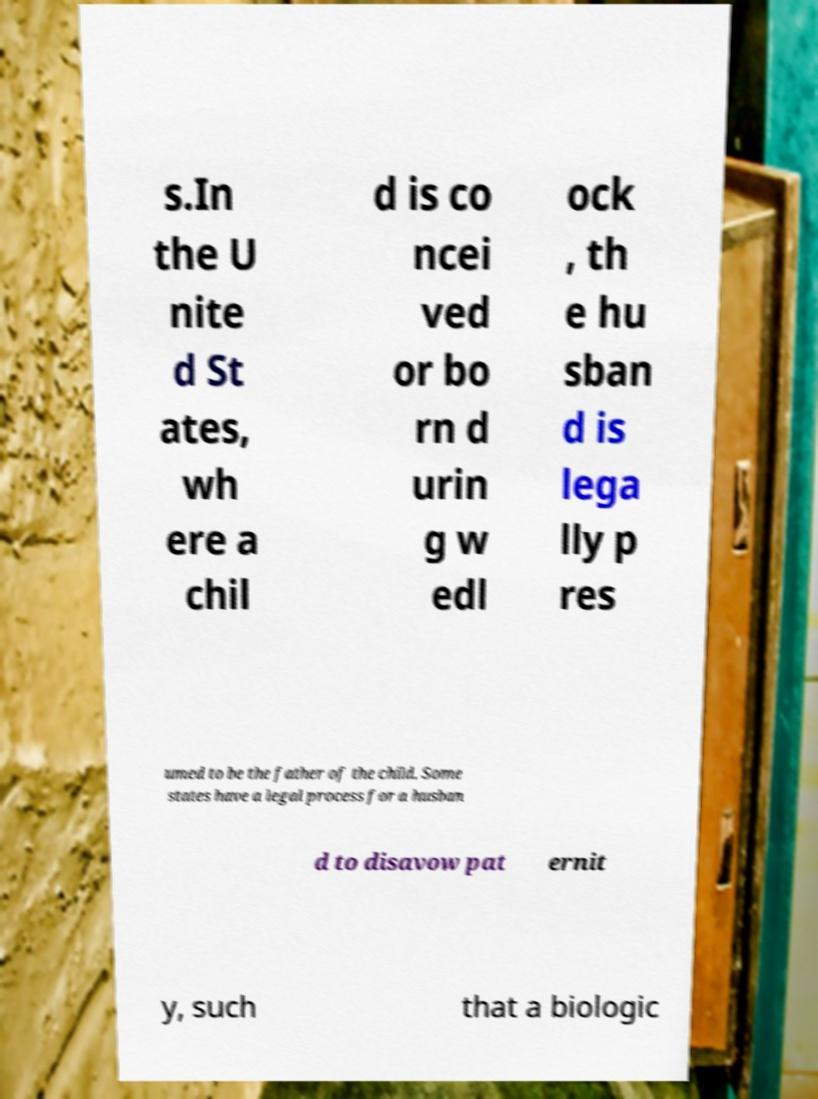Can you accurately transcribe the text from the provided image for me? s.In the U nite d St ates, wh ere a chil d is co ncei ved or bo rn d urin g w edl ock , th e hu sban d is lega lly p res umed to be the father of the child. Some states have a legal process for a husban d to disavow pat ernit y, such that a biologic 